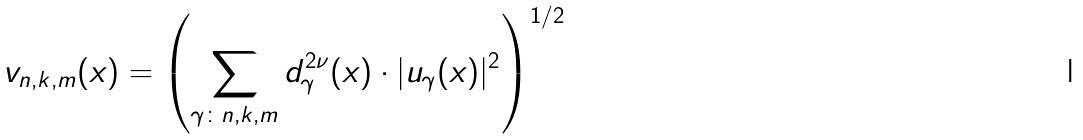<formula> <loc_0><loc_0><loc_500><loc_500>v _ { n , k , m } ( x ) = \left ( \sum _ { \gamma \colon n , k , m } d _ { \gamma } ^ { 2 \nu } ( x ) \cdot | u _ { \gamma } ( x ) | ^ { 2 } \right ) ^ { 1 / 2 }</formula> 